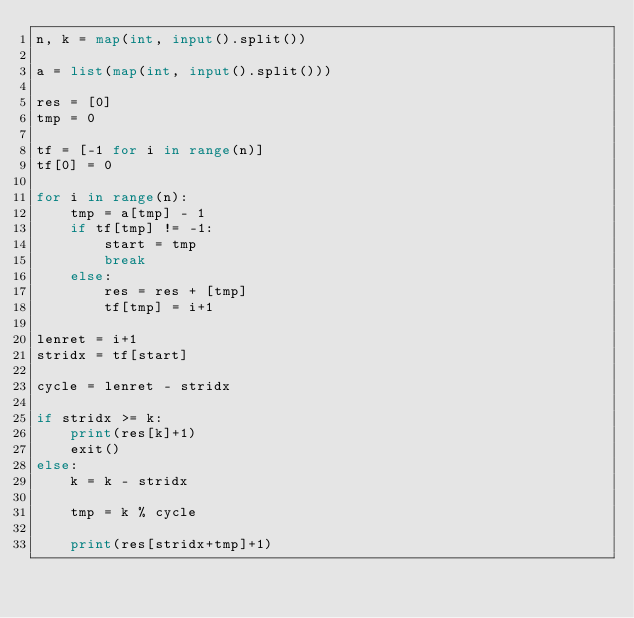Convert code to text. <code><loc_0><loc_0><loc_500><loc_500><_Python_>n, k = map(int, input().split())
 
a = list(map(int, input().split()))
 
res = [0]
tmp = 0
 
tf = [-1 for i in range(n)]
tf[0] = 0
 
for i in range(n):
    tmp = a[tmp] - 1
    if tf[tmp] != -1:
        start = tmp
        break
    else:
        res = res + [tmp]
        tf[tmp] = i+1
 
lenret = i+1
stridx = tf[start]
 
cycle = lenret - stridx
 
if stridx >= k:
    print(res[k]+1)
    exit()
else:
    k = k - stridx
 
    tmp = k % cycle
 
    print(res[stridx+tmp]+1)</code> 